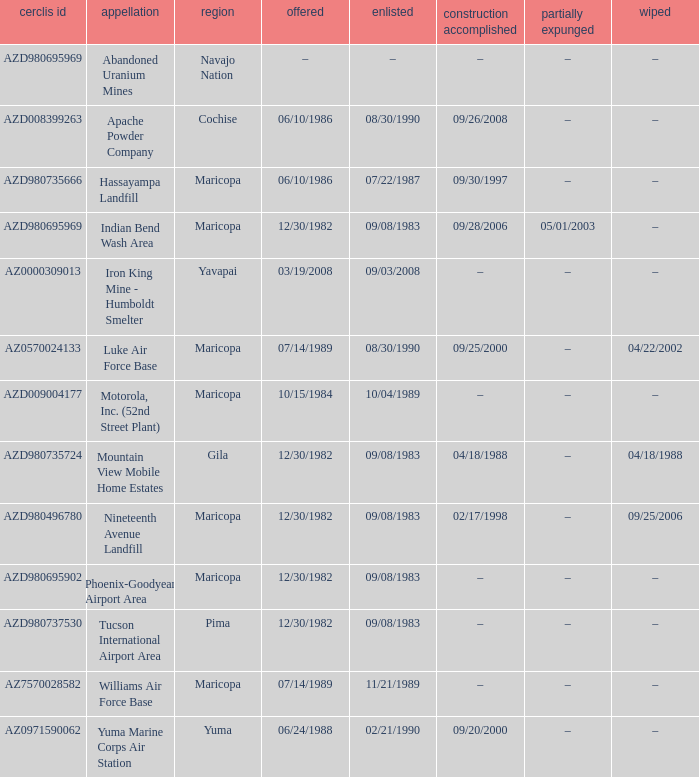What is the cerclis id when the site was proposed on 12/30/1982 and was partially deleted on 05/01/2003? AZD980695969. 